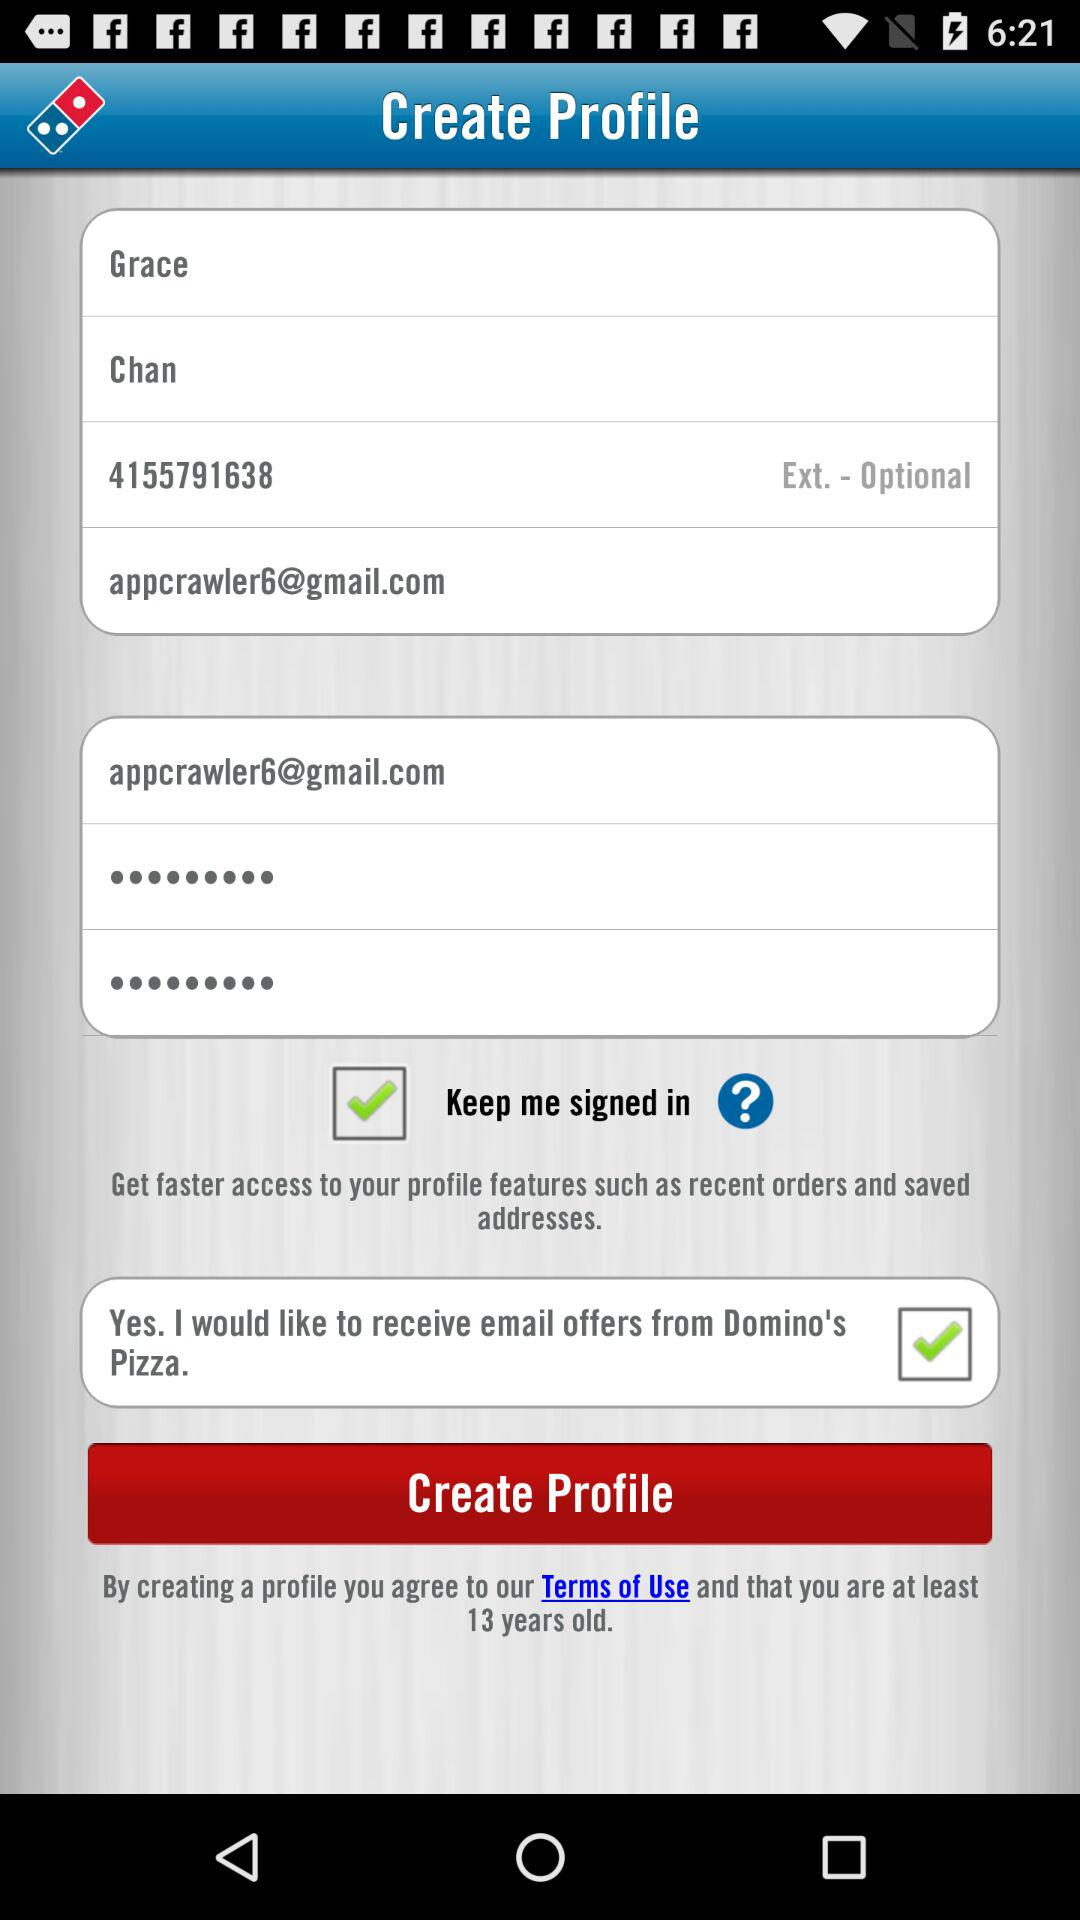What is the status of the "Keep me signed in" setting? The status is "on". 